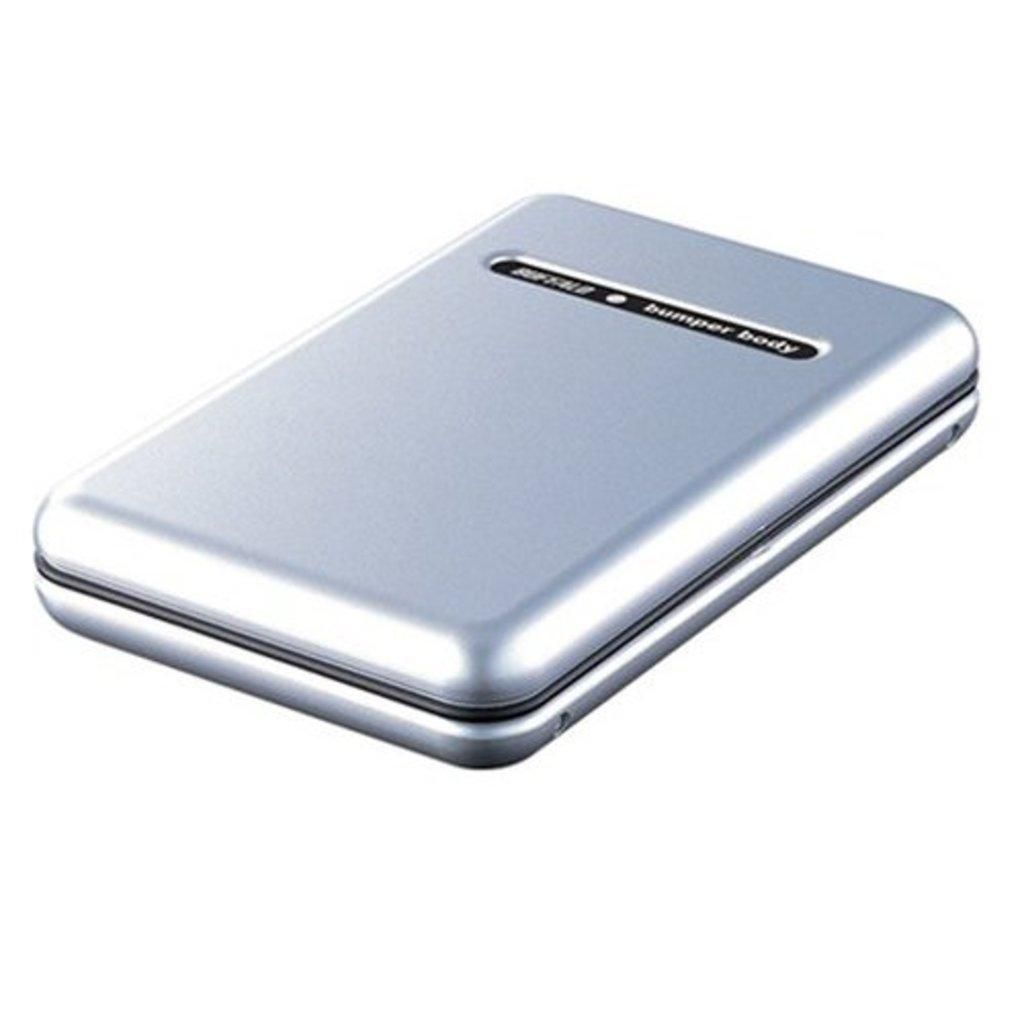<image>
Offer a succinct explanation of the picture presented. A silver case with the words bumper body written on it. 